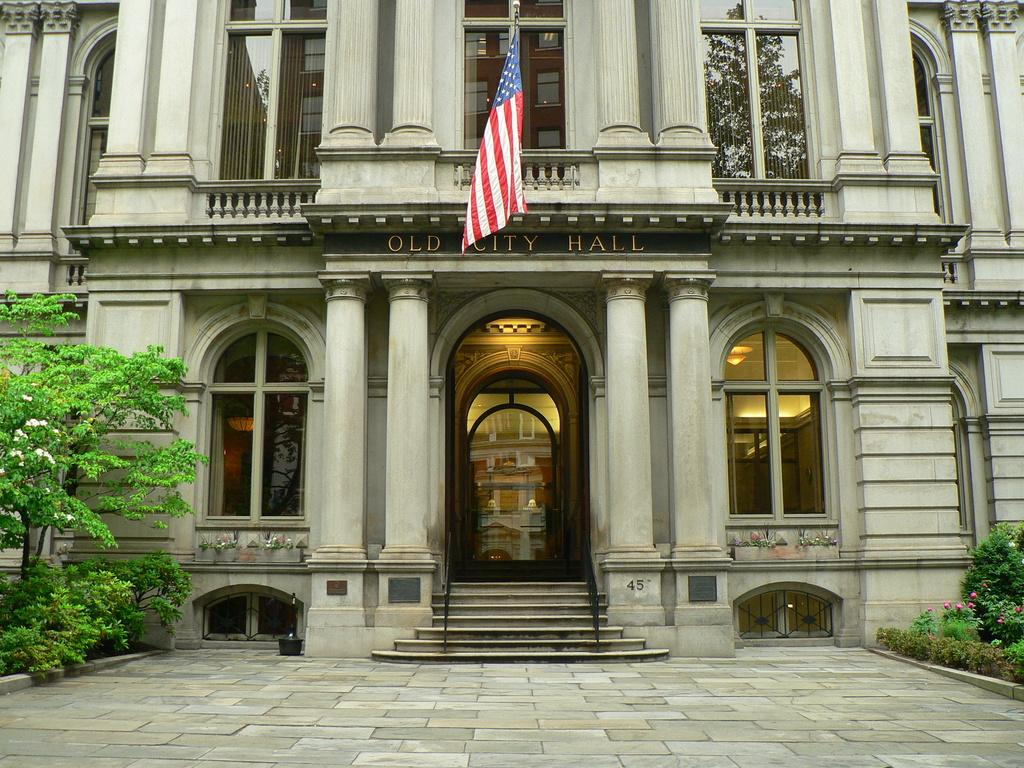What type of structure is visible in the image? There is a building in the image. What decorative elements can be seen on the building? There are flags in the image. What architectural features are present on the building? There are windows, pillars, and a staircase in the image. What safety features are present on the building? There are railings in the image. What natural elements are present in the image? There are trees, bushes, and shrubs in the image. Can you hear the drum being played in the image? There is no drum present in the image, so it cannot be heard. What type of underwear is hanging on the building in the image? There is no underwear present in the image. 